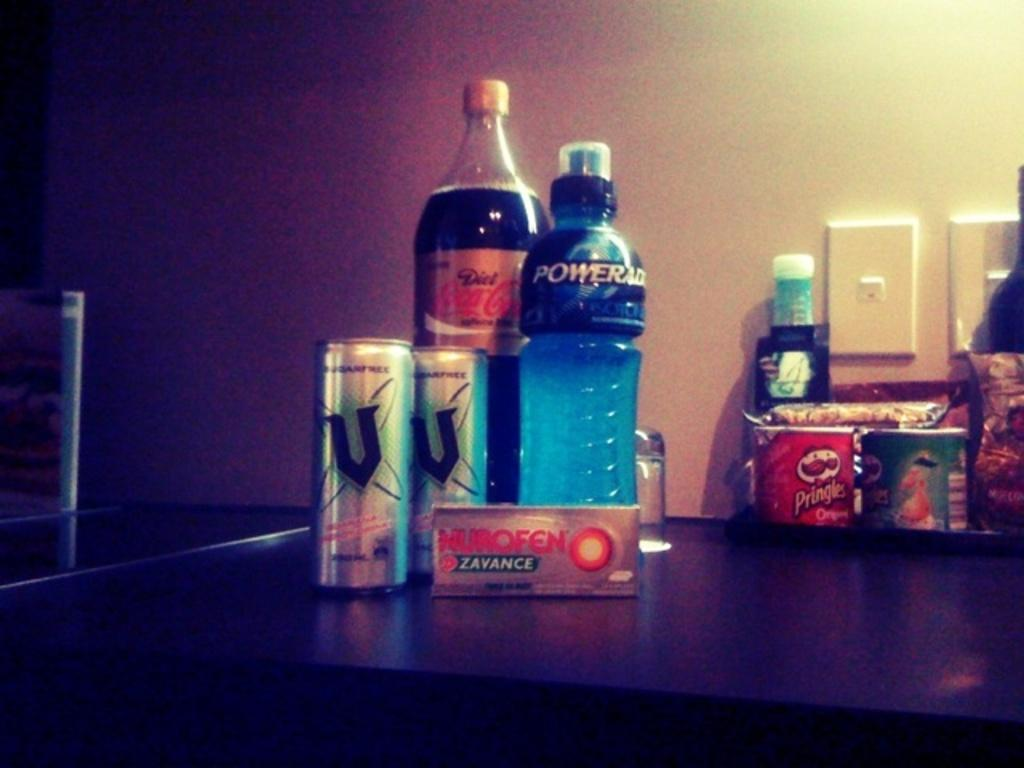<image>
Share a concise interpretation of the image provided. Bottle of gatorade,pop,enegery drink and ibuprofen on a table. 